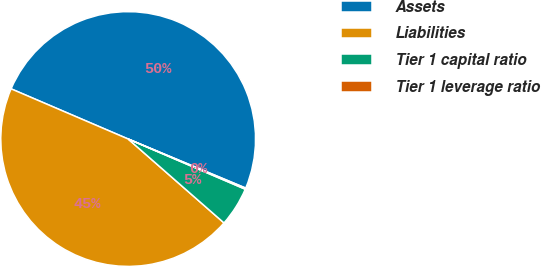Convert chart to OTSL. <chart><loc_0><loc_0><loc_500><loc_500><pie_chart><fcel>Assets<fcel>Liabilities<fcel>Tier 1 capital ratio<fcel>Tier 1 leverage ratio<nl><fcel>49.85%<fcel>45.0%<fcel>5.0%<fcel>0.15%<nl></chart> 